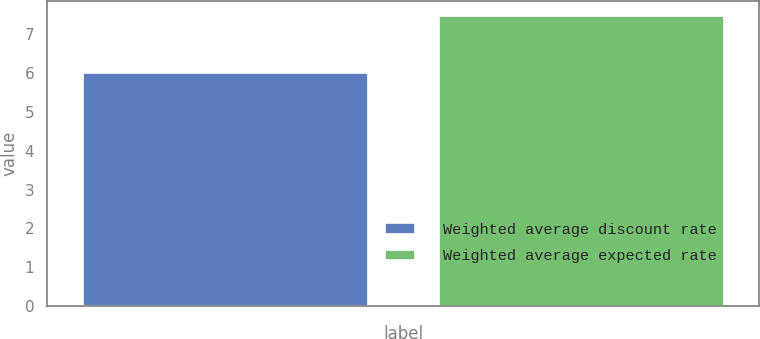<chart> <loc_0><loc_0><loc_500><loc_500><bar_chart><fcel>Weighted average discount rate<fcel>Weighted average expected rate<nl><fcel>6<fcel>7.47<nl></chart> 